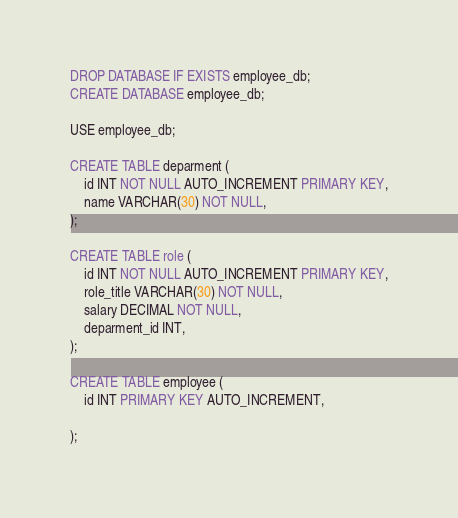Convert code to text. <code><loc_0><loc_0><loc_500><loc_500><_SQL_>DROP DATABASE IF EXISTS employee_db;
CREATE DATABASE employee_db;

USE employee_db;

CREATE TABLE deparment (
    id INT NOT NULL AUTO_INCREMENT PRIMARY KEY,
    name VARCHAR(30) NOT NULL,
);

CREATE TABLE role (
    id INT NOT NULL AUTO_INCREMENT PRIMARY KEY,
    role_title VARCHAR(30) NOT NULL,
    salary DECIMAL NOT NULL,
    deparment_id INT,
);

CREATE TABLE employee (
    id INT PRIMARY KEY AUTO_INCREMENT,
    
);</code> 